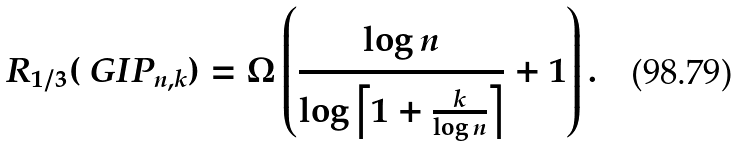Convert formula to latex. <formula><loc_0><loc_0><loc_500><loc_500>R _ { 1 / 3 } ( \ G I P _ { n , k } ) & = \Omega \left ( \frac { \log n } { \log \left \lceil 1 + \frac { k } { \log n } \right \rceil } + 1 \right ) .</formula> 